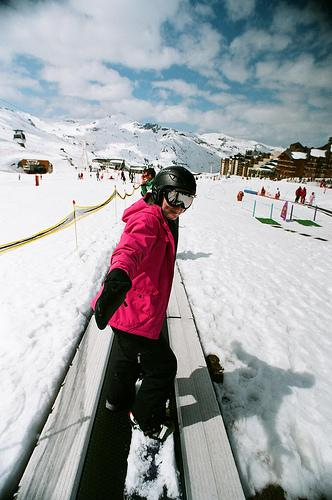What can be inferred about the woman's snowboarding skills from the image? It's difficult to accurately infer her snowboarding skills from the image, but she seems to be comfortable on the snowboard and wearing proper safety gear. What is the primary activity taking place in the image? The primary activity is a woman snowboarding on a snow-covered mountain. How many bananas are mentioned in the image's image? There are 10 mentions of bananas in the image. List down five objects present in the image apart from the main subject. Blue poles, people playing in the snow, snowy mountains, white clouds on the sky, and the ground covered with snow. What are some safety equipment the woman is using while snowboarding? The woman is wearing a black helmet and black goggles as safety equipment while snowboarding. Provide a brief description of the scene captured in the image. The image shows a woman snowboarding on a snow-covered mountain, wearing a pink jacket, black pants, and a black helmet with goggles. There are people playing in the snow and blue poles in the background. Identify any potential discrepancies between the image and the main subject of the image. The image include multiple mentions of bananas, which are not relevant to the main subject of the image, which is a woman snowboarding. What color is the jacket worn by the woman in the image? The jacket worn by the woman is pink. What is the significance of the blue poles on the snow? The blue poles on the snow might be markers or barriers, providing guidance or boundaries for the snowboarding or skiing area. Explain the weather conditions depicted in the image. The weather conditions in the image are cold and snowy, as seen by the snow-covered ground, mountains, and the presence of people playing in the snow. 